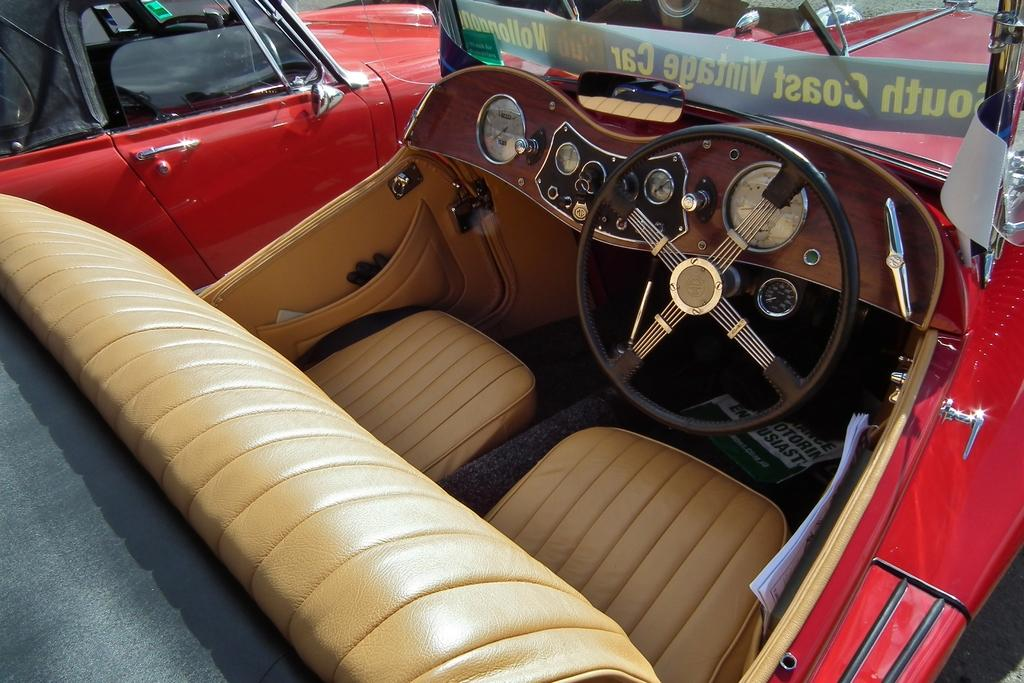What is the main subject of the image? There is a car in the center of the image. Are there any other cars visible in the image? Yes, there is another car in the background of the image. What statement does the ladybug make while sitting on the car in the image? There is no ladybug present in the image, so it cannot make any statements. 